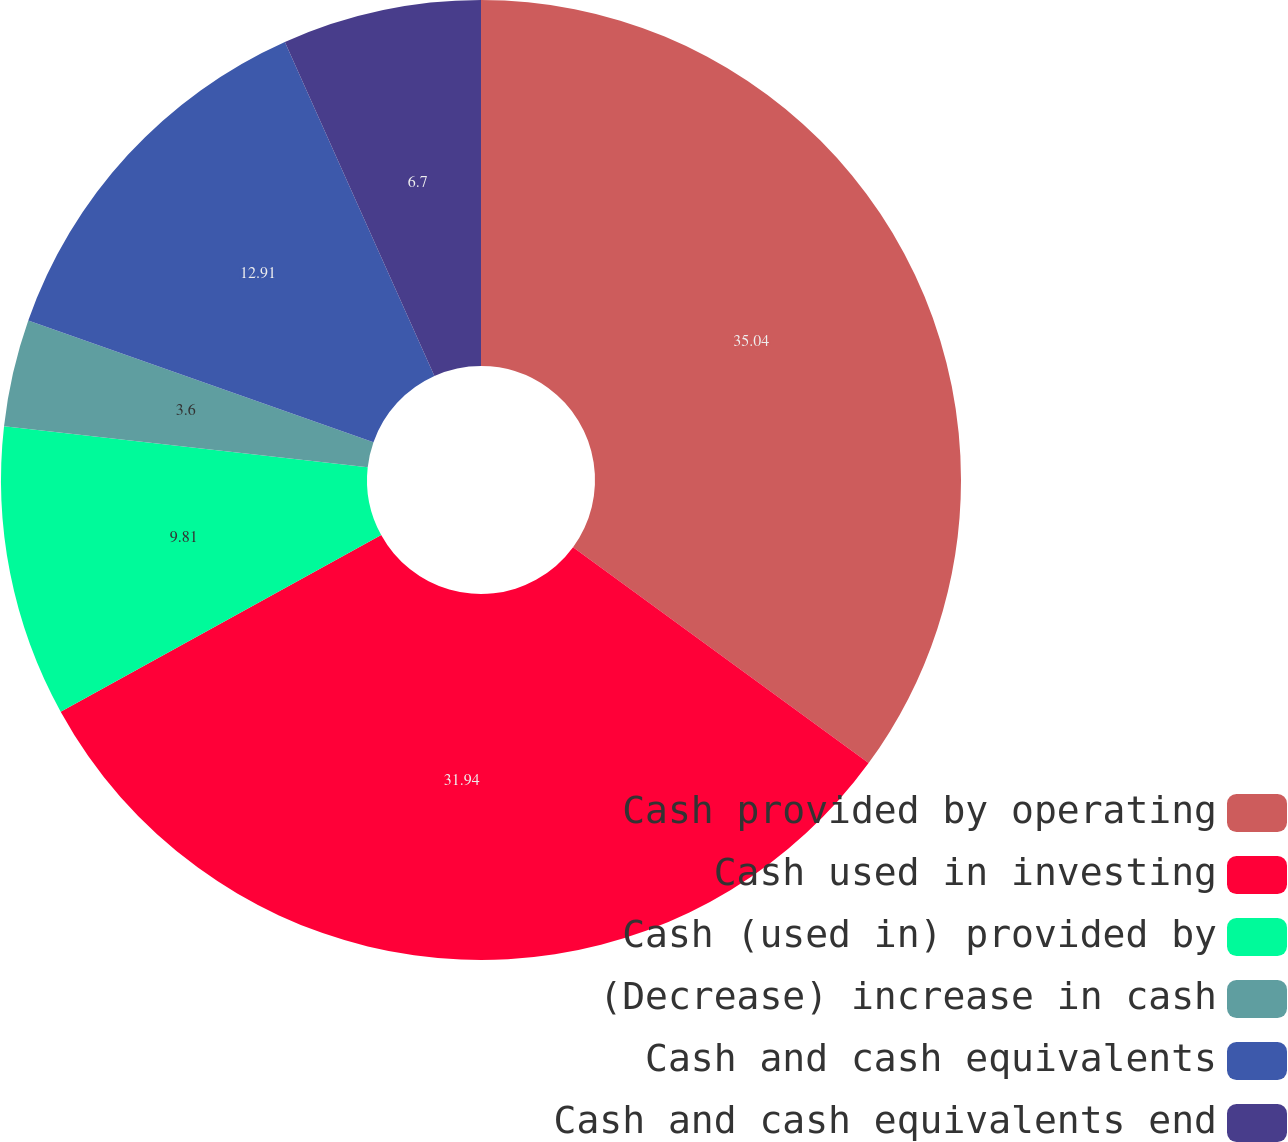Convert chart. <chart><loc_0><loc_0><loc_500><loc_500><pie_chart><fcel>Cash provided by operating<fcel>Cash used in investing<fcel>Cash (used in) provided by<fcel>(Decrease) increase in cash<fcel>Cash and cash equivalents<fcel>Cash and cash equivalents end<nl><fcel>35.04%<fcel>31.94%<fcel>9.81%<fcel>3.6%<fcel>12.91%<fcel>6.7%<nl></chart> 